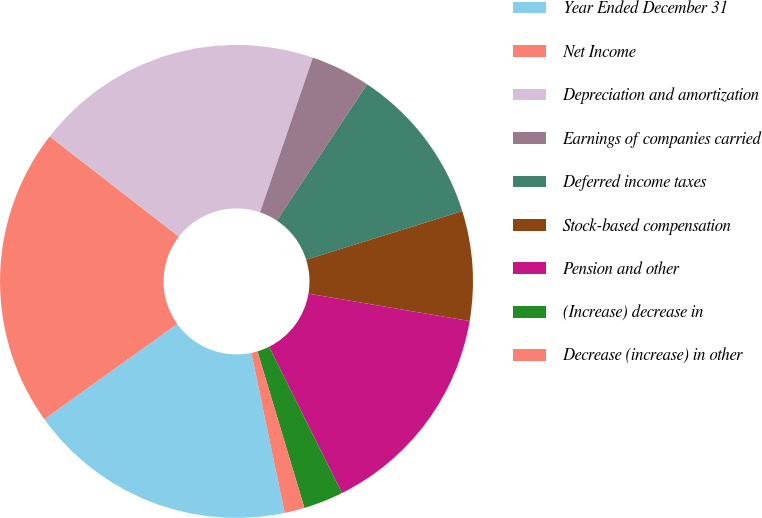<chart> <loc_0><loc_0><loc_500><loc_500><pie_chart><fcel>Year Ended December 31<fcel>Net Income<fcel>Depreciation and amortization<fcel>Earnings of companies carried<fcel>Deferred income taxes<fcel>Stock-based compensation<fcel>Pension and other<fcel>(Increase) decrease in<fcel>Decrease (increase) in other<nl><fcel>18.36%<fcel>20.4%<fcel>19.72%<fcel>4.08%<fcel>10.88%<fcel>7.48%<fcel>14.96%<fcel>2.72%<fcel>1.37%<nl></chart> 